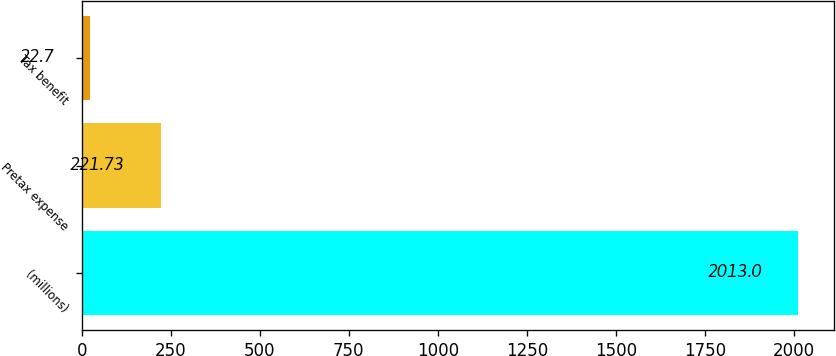<chart> <loc_0><loc_0><loc_500><loc_500><bar_chart><fcel>(millions)<fcel>Pretax expense<fcel>Tax benefit<nl><fcel>2013<fcel>221.73<fcel>22.7<nl></chart> 